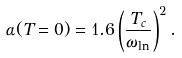<formula> <loc_0><loc_0><loc_500><loc_500>\alpha ( T = 0 ) = 1 . 6 \left ( \frac { T _ { c } } { \omega _ { \ln } } \right ) ^ { 2 } .</formula> 